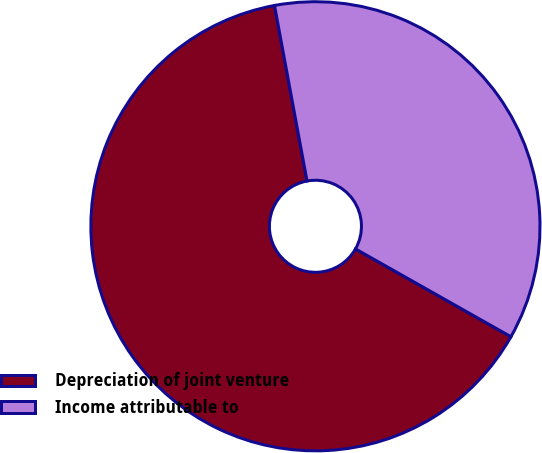<chart> <loc_0><loc_0><loc_500><loc_500><pie_chart><fcel>Depreciation of joint venture<fcel>Income attributable to<nl><fcel>63.9%<fcel>36.1%<nl></chart> 